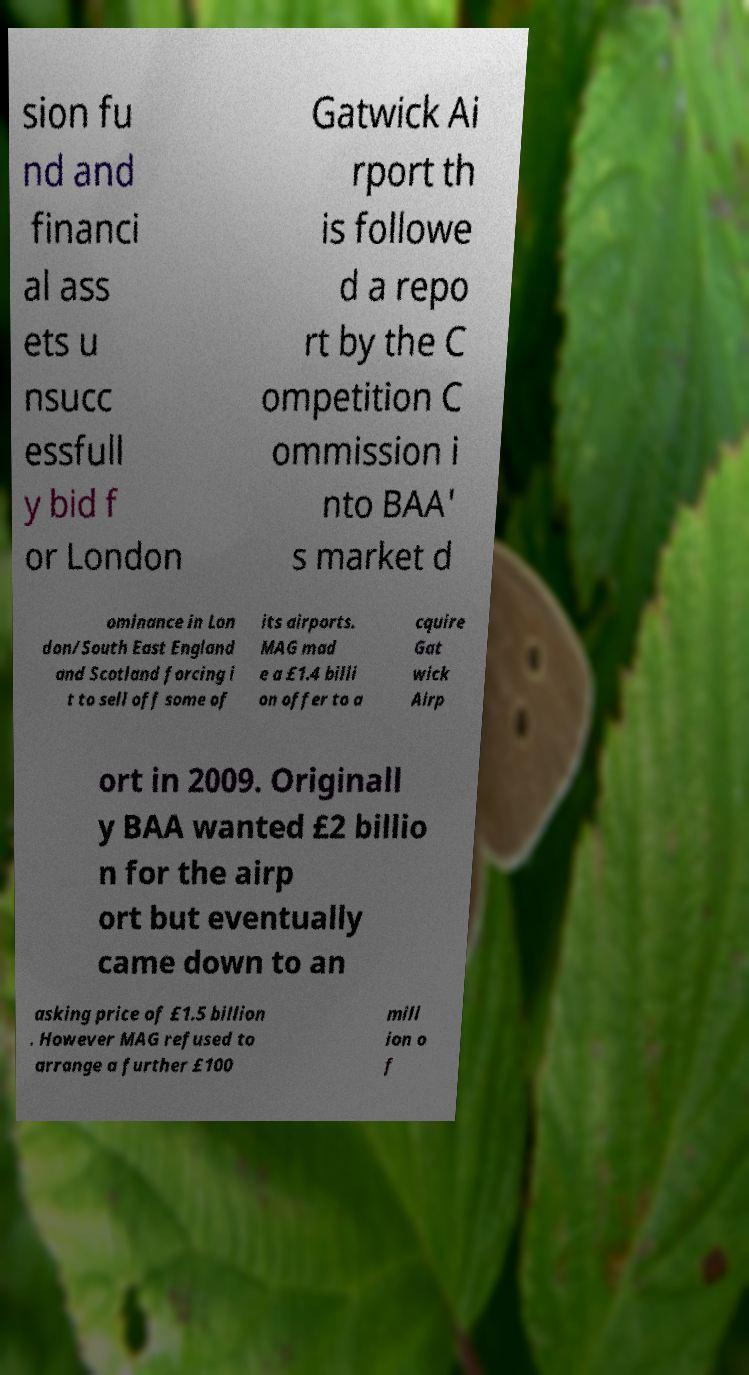For documentation purposes, I need the text within this image transcribed. Could you provide that? sion fu nd and financi al ass ets u nsucc essfull y bid f or London Gatwick Ai rport th is followe d a repo rt by the C ompetition C ommission i nto BAA' s market d ominance in Lon don/South East England and Scotland forcing i t to sell off some of its airports. MAG mad e a £1.4 billi on offer to a cquire Gat wick Airp ort in 2009. Originall y BAA wanted £2 billio n for the airp ort but eventually came down to an asking price of £1.5 billion . However MAG refused to arrange a further £100 mill ion o f 